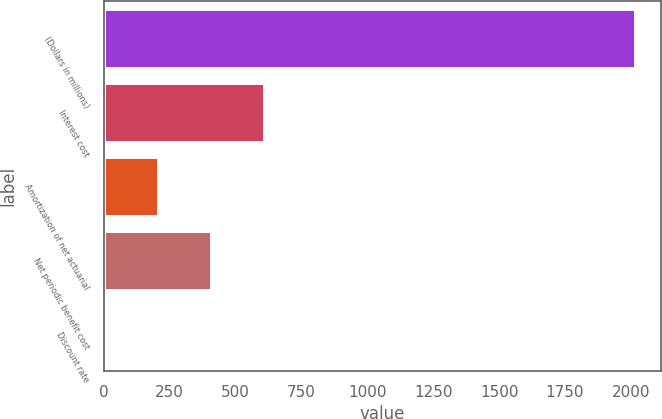Convert chart to OTSL. <chart><loc_0><loc_0><loc_500><loc_500><bar_chart><fcel>(Dollars in millions)<fcel>Interest cost<fcel>Amortization of net actuarial<fcel>Net periodic benefit cost<fcel>Discount rate<nl><fcel>2014<fcel>607.39<fcel>205.5<fcel>406.45<fcel>4.55<nl></chart> 